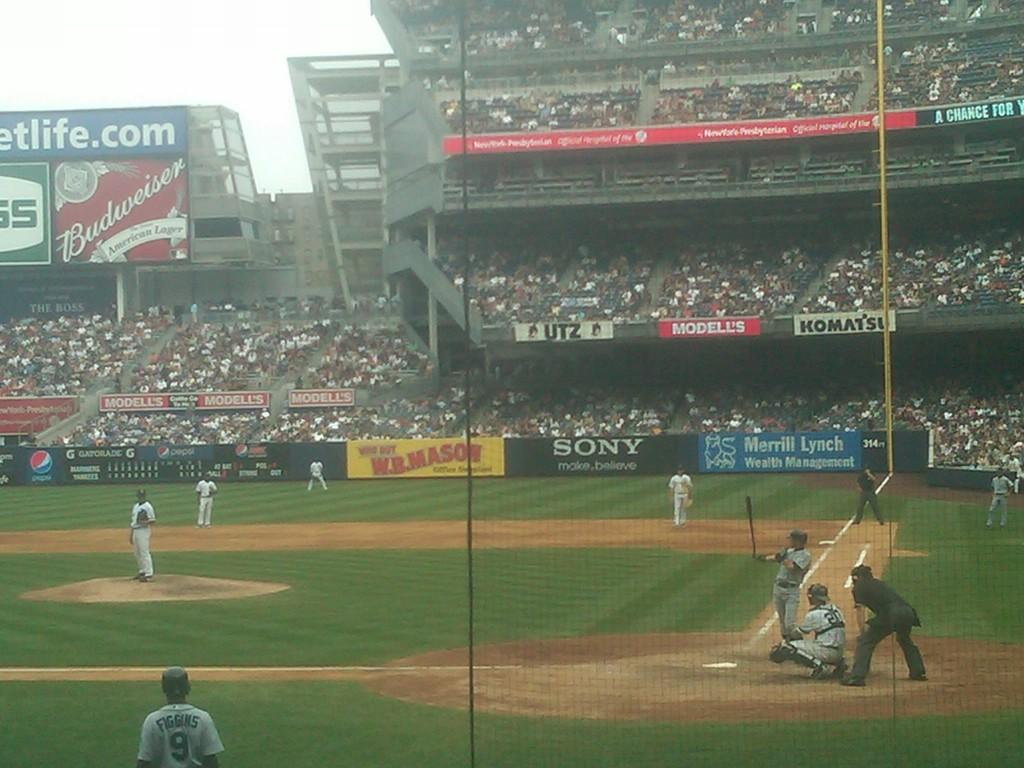<image>
Relay a brief, clear account of the picture shown. With a baseablle game ongoing the players are surrounded by advertising signs, one clear one being for SONY. 